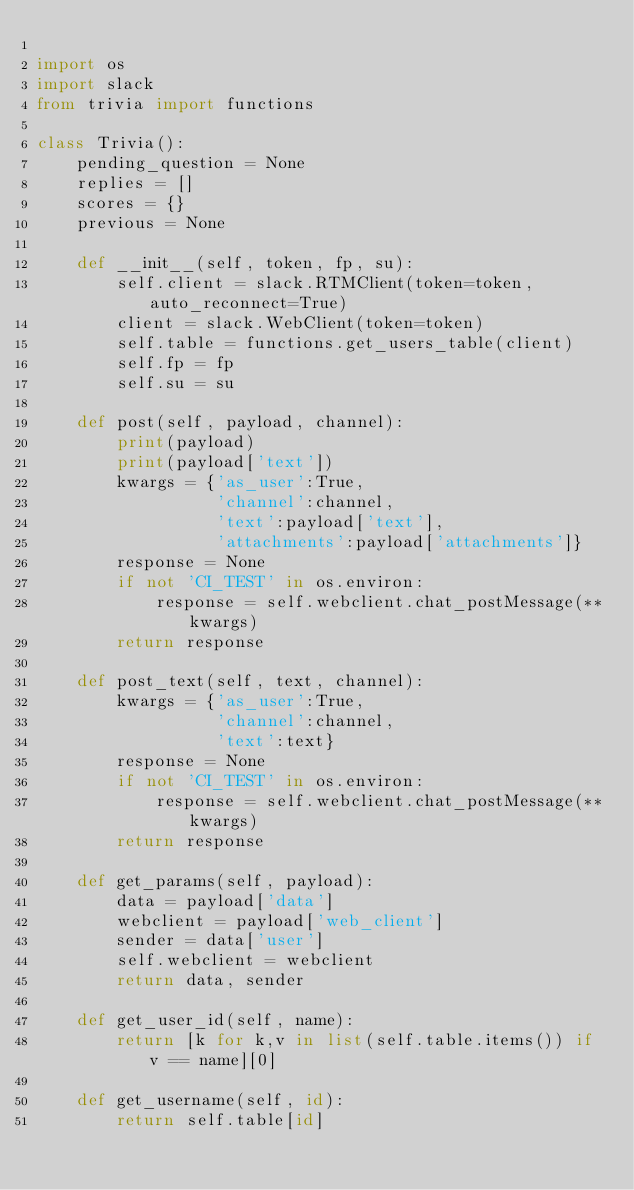<code> <loc_0><loc_0><loc_500><loc_500><_Python_>
import os
import slack
from trivia import functions

class Trivia():
    pending_question = None
    replies = []
    scores = {}
    previous = None

    def __init__(self, token, fp, su):
        self.client = slack.RTMClient(token=token, auto_reconnect=True)
        client = slack.WebClient(token=token)
        self.table = functions.get_users_table(client)
        self.fp = fp
        self.su = su

    def post(self, payload, channel):
        print(payload)
        print(payload['text'])
        kwargs = {'as_user':True,
                  'channel':channel,
                  'text':payload['text'],
                  'attachments':payload['attachments']}
        response = None
        if not 'CI_TEST' in os.environ:
            response = self.webclient.chat_postMessage(**kwargs)
        return response

    def post_text(self, text, channel):
        kwargs = {'as_user':True,
                  'channel':channel,
                  'text':text}
        response = None
        if not 'CI_TEST' in os.environ:
            response = self.webclient.chat_postMessage(**kwargs)
        return response

    def get_params(self, payload):
        data = payload['data']
        webclient = payload['web_client']
        sender = data['user']
        self.webclient = webclient
        return data, sender

    def get_user_id(self, name):
        return [k for k,v in list(self.table.items()) if v == name][0]

    def get_username(self, id):
        return self.table[id]
</code> 